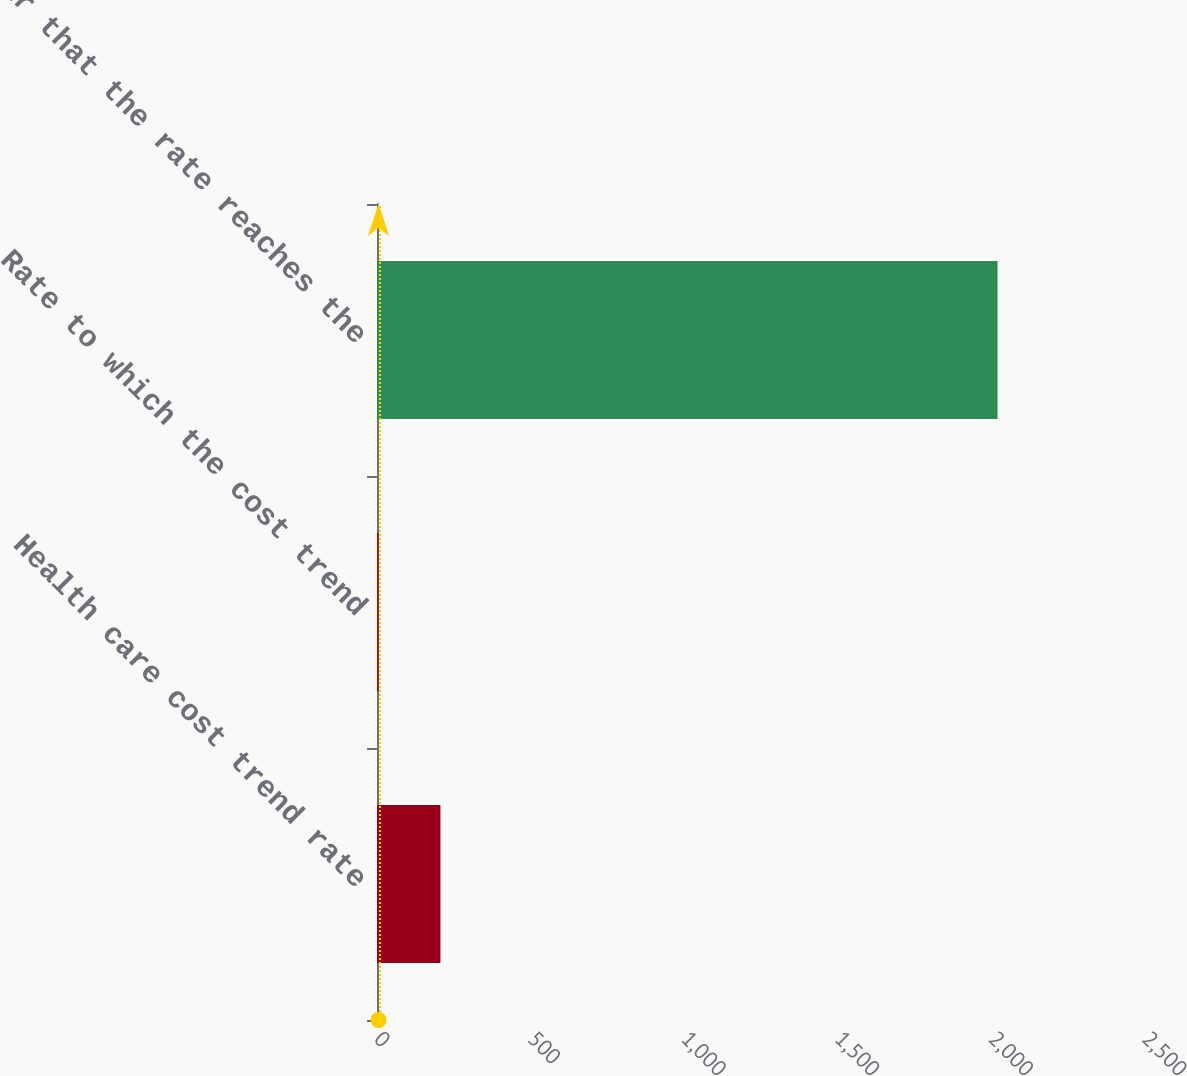<chart> <loc_0><loc_0><loc_500><loc_500><bar_chart><fcel>Health care cost trend rate<fcel>Rate to which the cost trend<fcel>Year that the rate reaches the<nl><fcel>206.5<fcel>5<fcel>2020<nl></chart> 